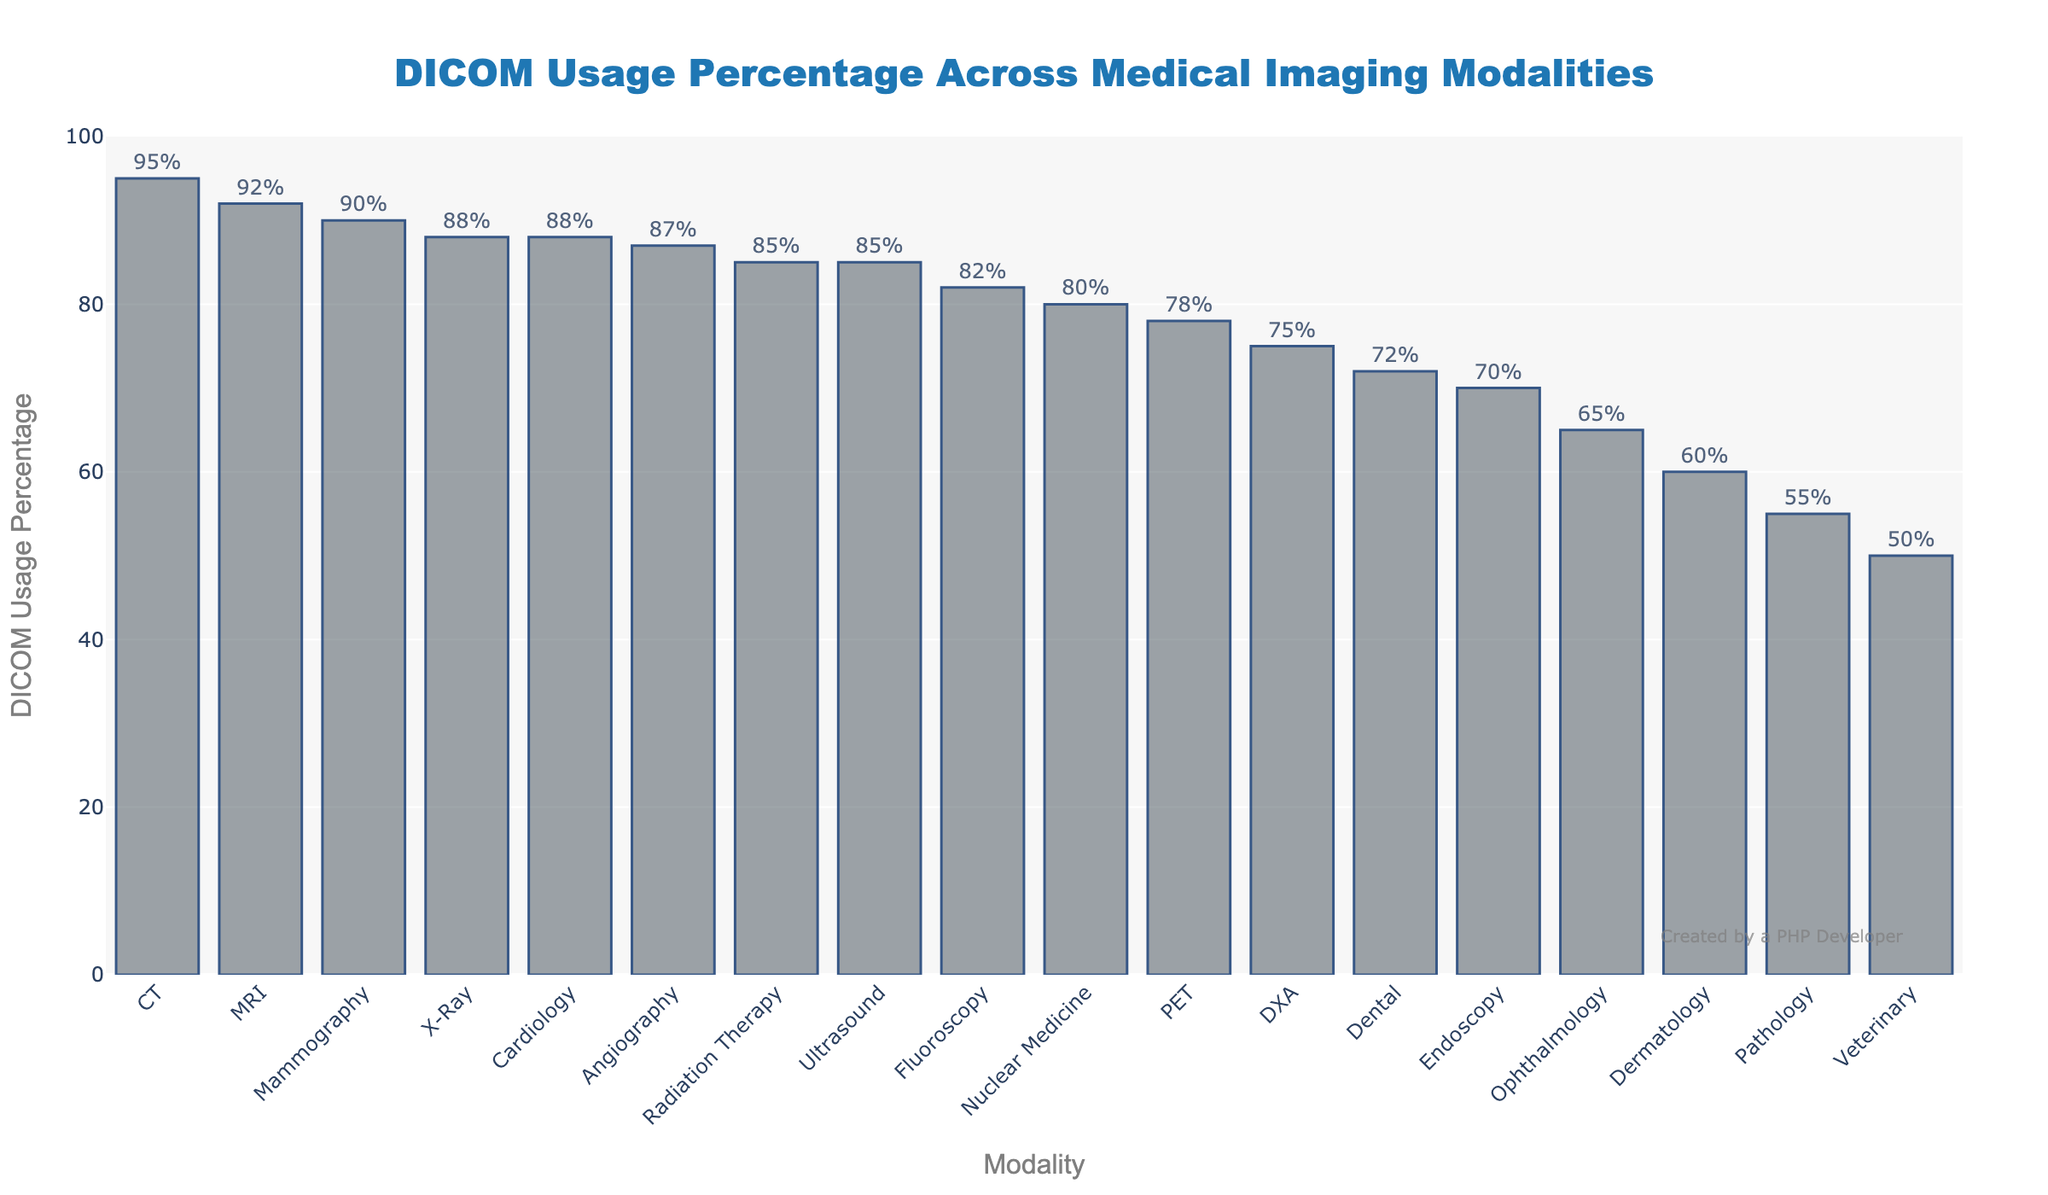What's the DICOM usage percentage for CT? The value of the bar corresponding to "CT" gives the DICOM usage percentage for this modality. This bar is positioned at 95 on the y-axis.
Answer: 95% Which modality has the lowest DICOM usage percentage? The shortest bar in the chart represents the modality with the lowest DICOM usage percentage. For this figure, "Veterinary" has the shortest bar, indicating the lowest percentage.
Answer: Veterinary What is the difference in DICOM usage percentage between MRI and Ultrasound? Locate the bars for MRI and Ultrasound. The heights of these bars correspond to 92 and 85, respectively. Subtract the smaller value from the larger one (92 - 85).
Answer: 7% What is the average DICOM usage percentage for the imaging modalities that have percentages above 90%? Identify the modalities with usage percentages above 90%: CT (95), MRI (92), and Mammography (90). Calculate the average by summing their percentages and dividing by the number of modalities: (95 + 92 + 90) / 3.
Answer: 92.33% Which modalities have exactly 88% DICOM usage percentage? Find the bars with the height at 88 on the y-axis. There are two bars corresponding to "X-Ray" and "Cardiology".
Answer: X-Ray, Cardiology Are there any modalities with a DICOM usage percentage between 60% and 70%? Check the chart for bars whose height falls between 60 and 70 on the y-axis. "Dermatology" at 60 and "Ophthalmology" at 65 fall in this range.
Answer: Ophthalmology What is the sum of the DICOM usage percentages for Nuclear Medicine, PET, and DXA? Locate the bars for Nuclear Medicine, PET, and DXA. Their heights indicate 80, 78, and 75 respectively. Sum these values (80 + 78 + 75).
Answer: 233 How many modalities have a DICOM usage percentage of 80% or higher? Count the bars that are at 80 or higher on the y-axis. The modalities are CT, MRI, X-Ray, Ultrasound, Nuclear Medicine, Mammography, Angiography, Fluoroscopy, Radiation Therapy, and Cardiology.
Answer: 10 Which modality has a higher DICOM usage percentage: Angiography or Fluoroscopy? Compare the heights of the bars for Angiography and Fluoroscopy. Angiography is at 87 and Fluoroscopy is at 82. Angiography has a higher percentage.
Answer: Angiography 